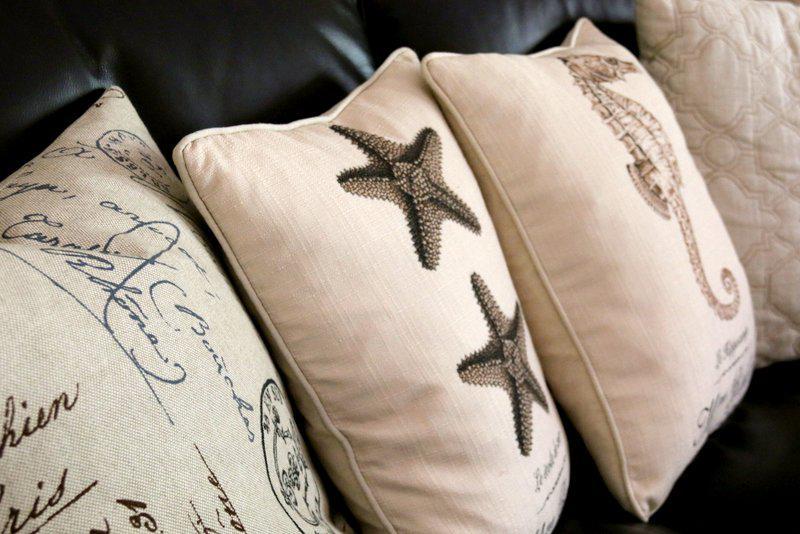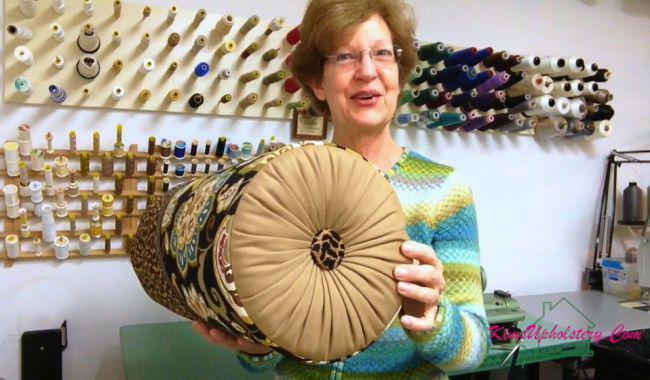The first image is the image on the left, the second image is the image on the right. Considering the images on both sides, is "In at least one image, a person is shown displaying fancy throw pillows." valid? Answer yes or no. Yes. 